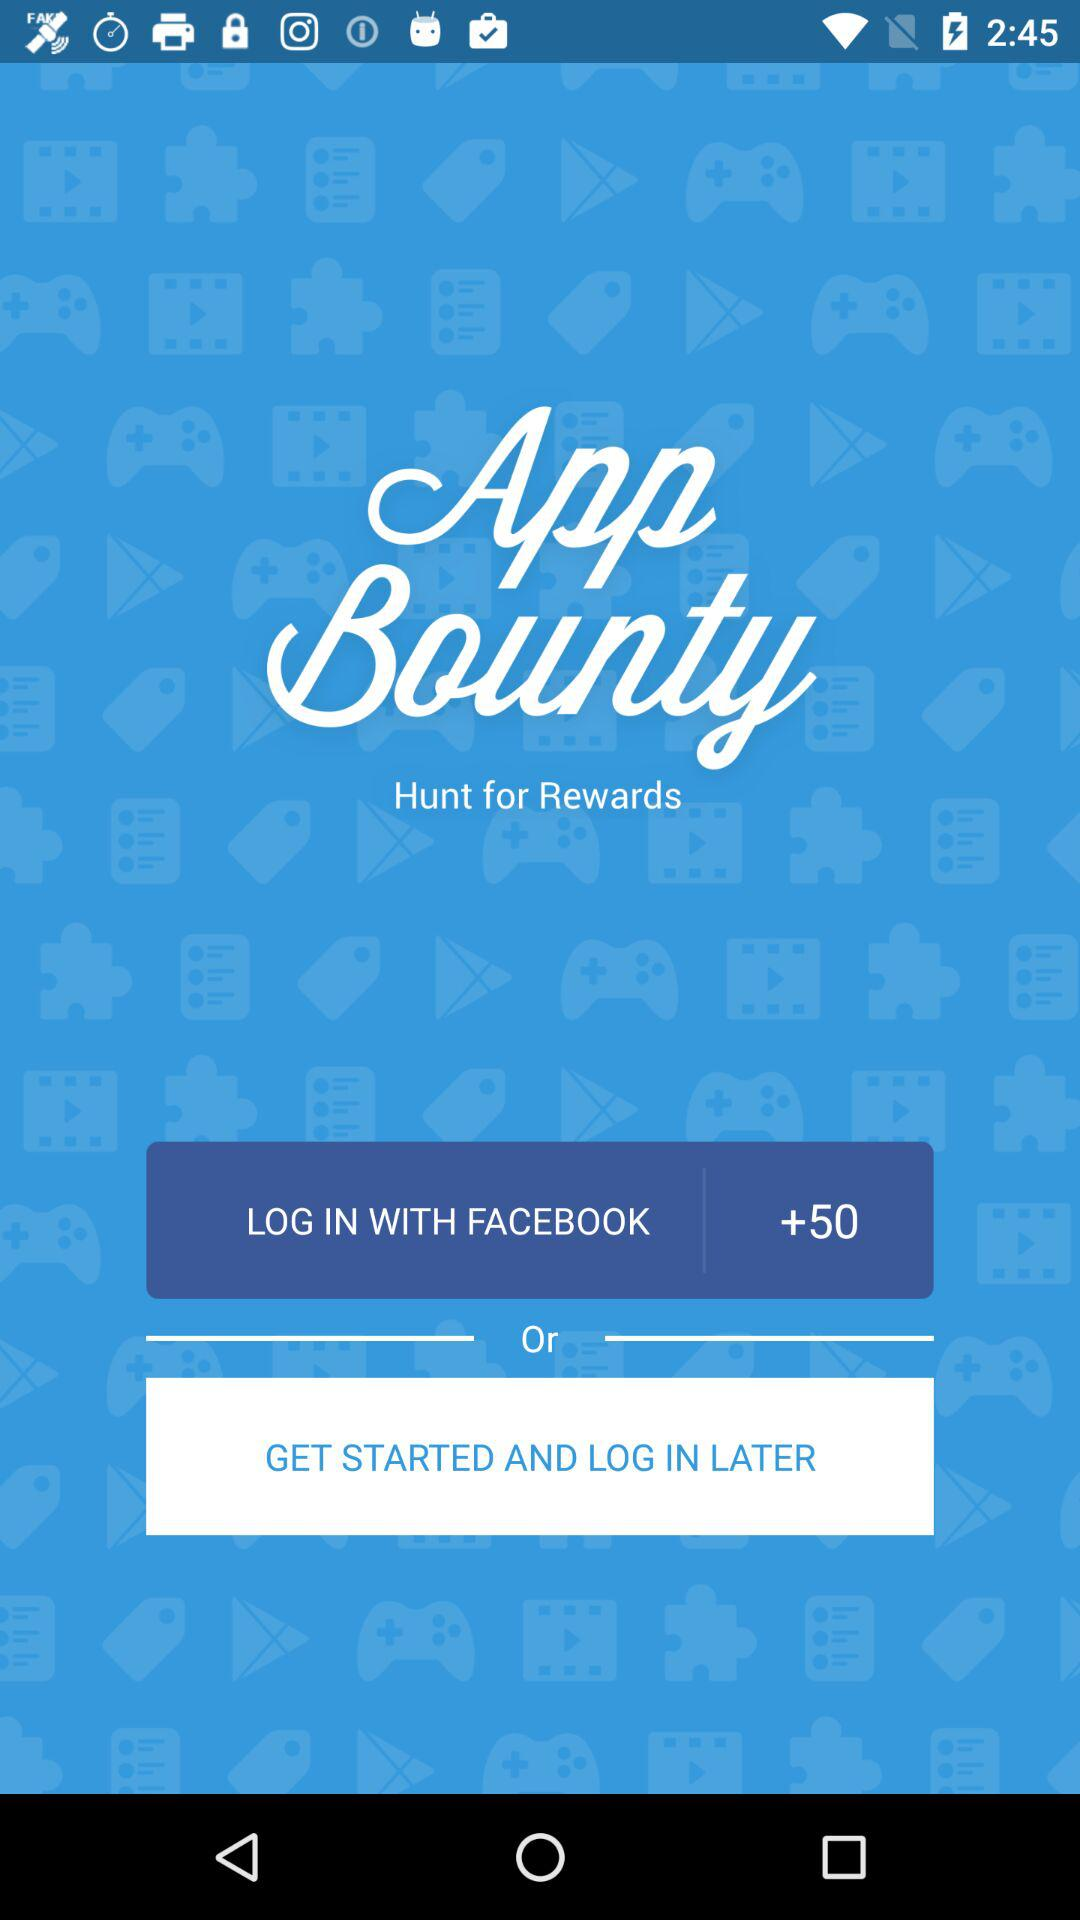How many people login with Facebook?
When the provided information is insufficient, respond with <no answer>. <no answer> 